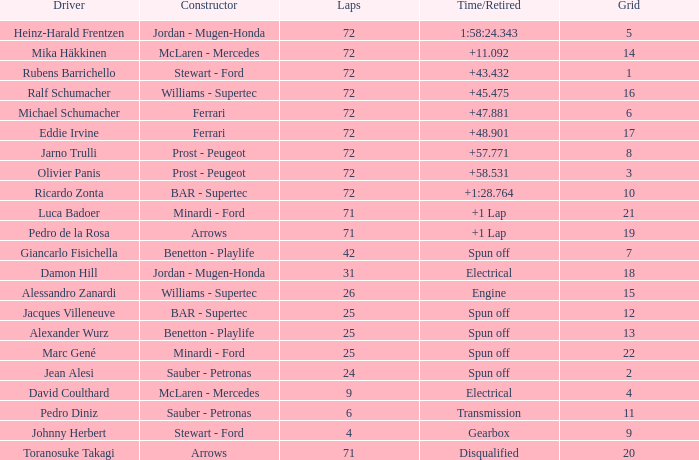What was Alexander Wurz's highest grid with laps of less than 25? None. 